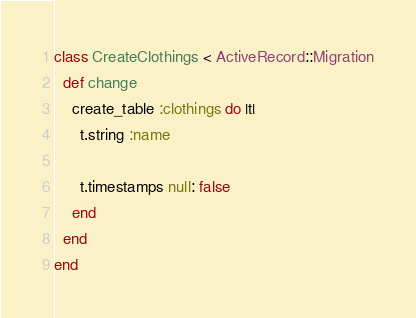<code> <loc_0><loc_0><loc_500><loc_500><_Ruby_>class CreateClothings < ActiveRecord::Migration
  def change
    create_table :clothings do |t|
      t.string :name

      t.timestamps null: false
    end
  end
end
</code> 